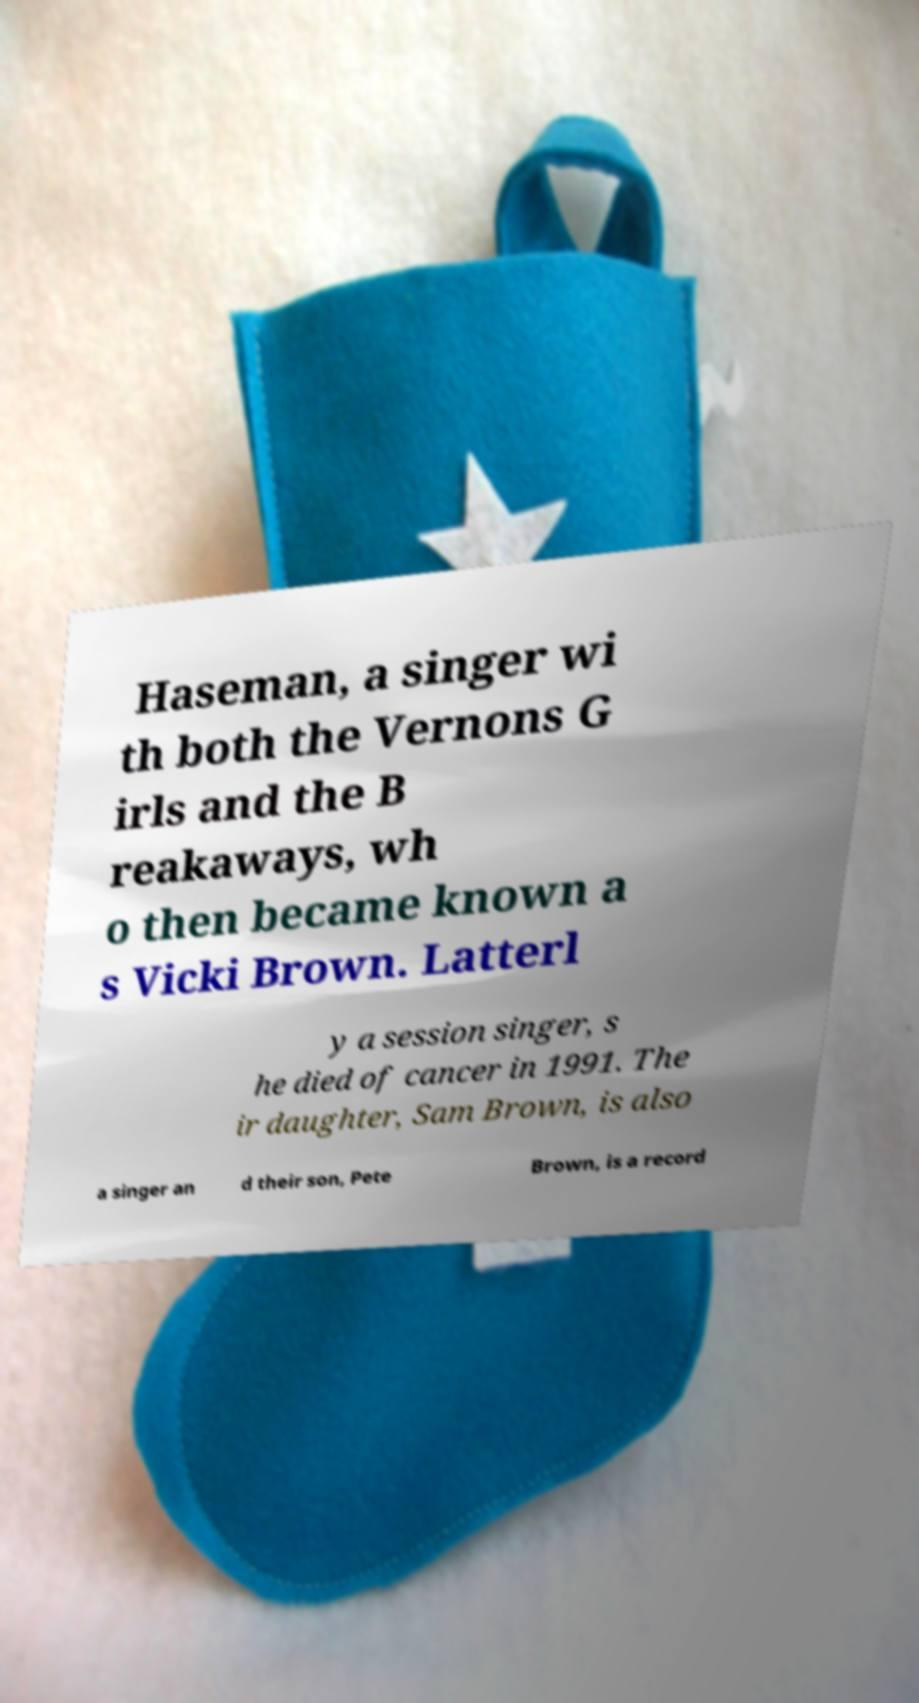Could you extract and type out the text from this image? Haseman, a singer wi th both the Vernons G irls and the B reakaways, wh o then became known a s Vicki Brown. Latterl y a session singer, s he died of cancer in 1991. The ir daughter, Sam Brown, is also a singer an d their son, Pete Brown, is a record 